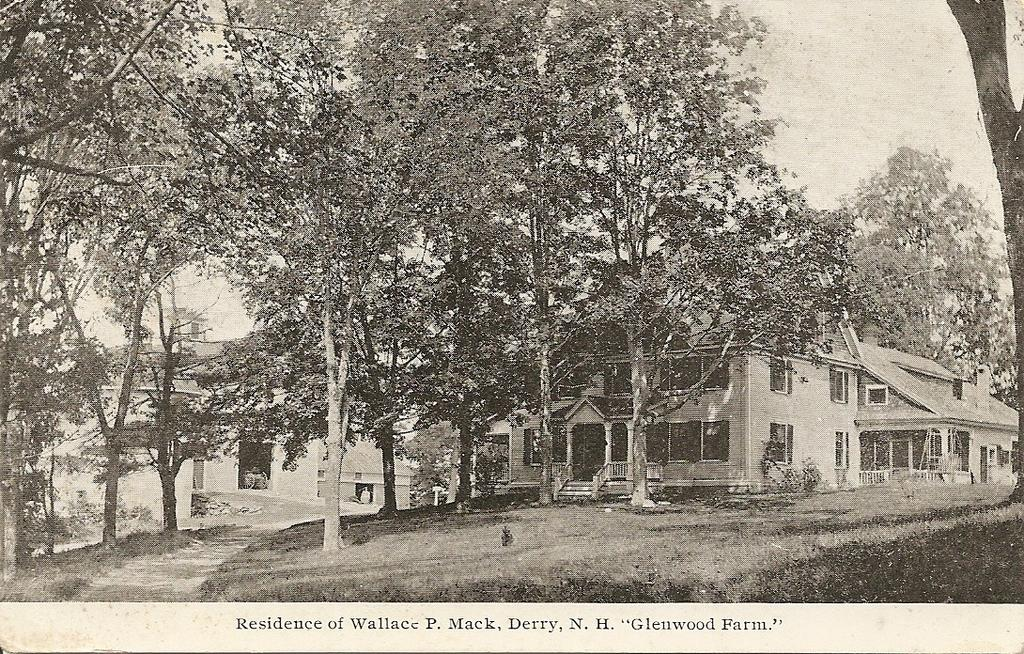What type of natural elements can be seen in the image? There are trees in the image. What type of man-made structures are present in the image? There are buildings in the image. What part of the natural environment is visible in the image? The sky is visible in the image. What is the color scheme of the image? The image is black and white in color. What is written on the image? There is something written on the image. What type of dinner is being served in the image? There is no dinner present in the image; it features trees, buildings, and a black and white color scheme. What shape is the health symbol in the image? There is no health symbol present in the image. 